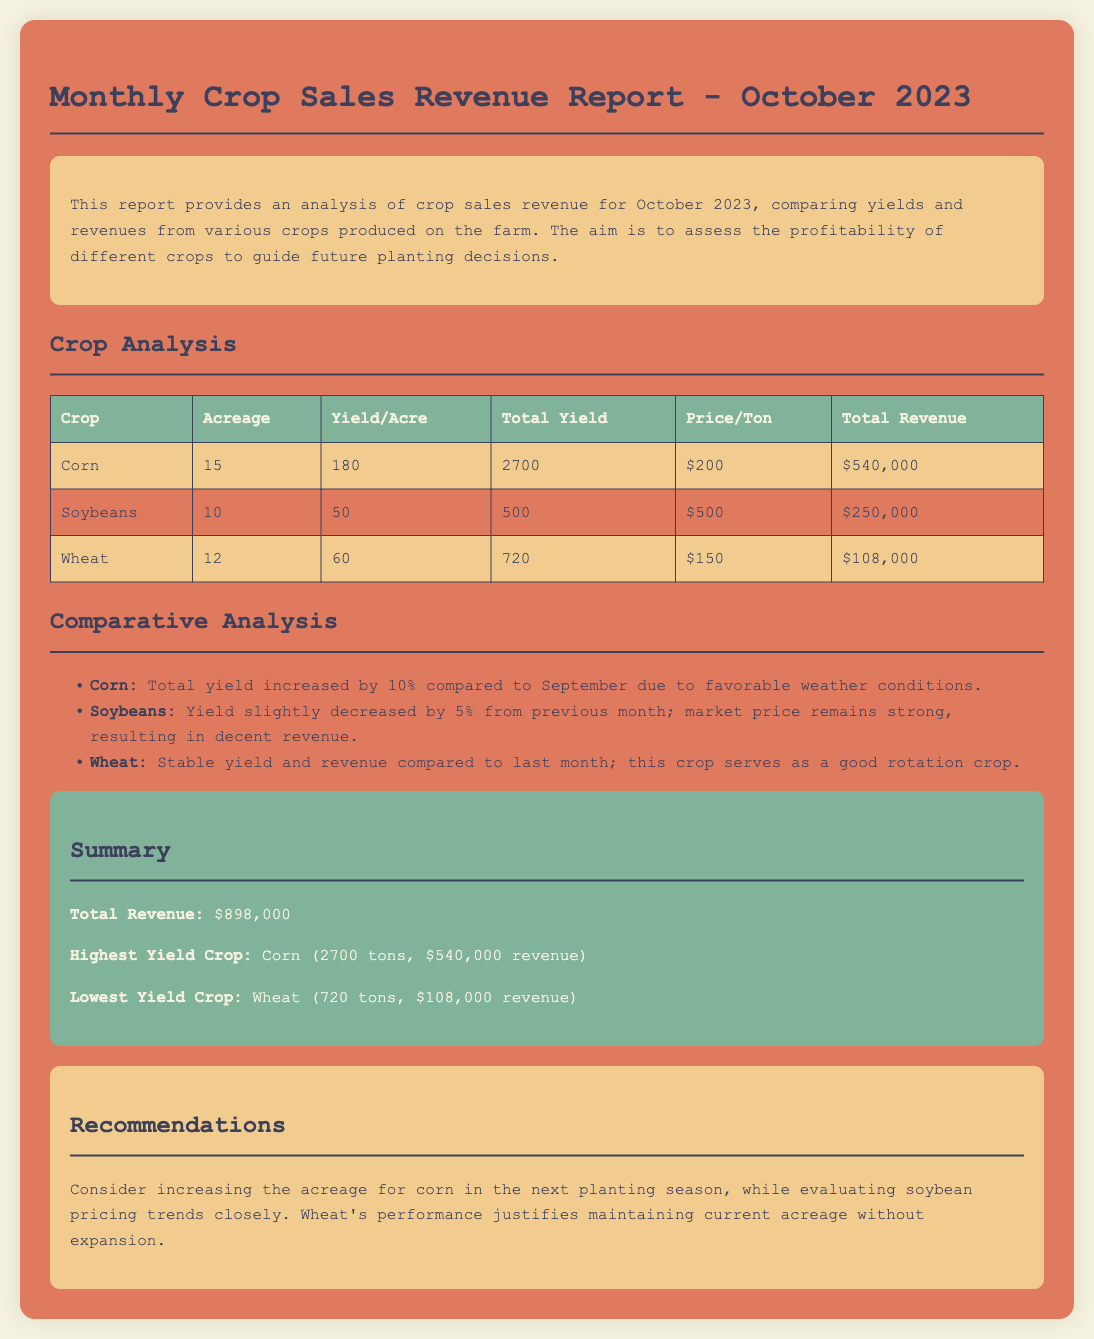what is the total revenue? The total revenue is calculated from all crops' total revenue, which sums up to $540,000 + $250,000 + $108,000.
Answer: $898,000 which crop had the highest yield? The highest yield crop is determined by comparing the total yield figures presented, resulting in Corn having the highest yield at 2700 tons.
Answer: Corn what is the price per ton of soybeans? The price per ton of soybeans is stated in the document to be $500.
Answer: $500 how much did wheat earn in total revenue? The total revenue for wheat is explicitly stated in the table, indicating that it earned $108,000.
Answer: $108,000 what recommendation is given for soybean? The recommendation focuses on closely evaluating soybean pricing trends to make informed decisions.
Answer: Evaluate pricing trends how many acres of corn were planted? The document specifies that 15 acres of corn were planted.
Answer: 15 by what percentage did corn's yield increase? The percentage increase in corn’s yield compared to September is explicitly noted as 10%.
Answer: 10% what crop serves as a good rotation crop? The document mentions wheat as a stable crop that serves as a good rotation crop.
Answer: Wheat how many tons of soybeans were produced? The total yield of soybeans is clearly indicated in the table as 500 tons.
Answer: 500 